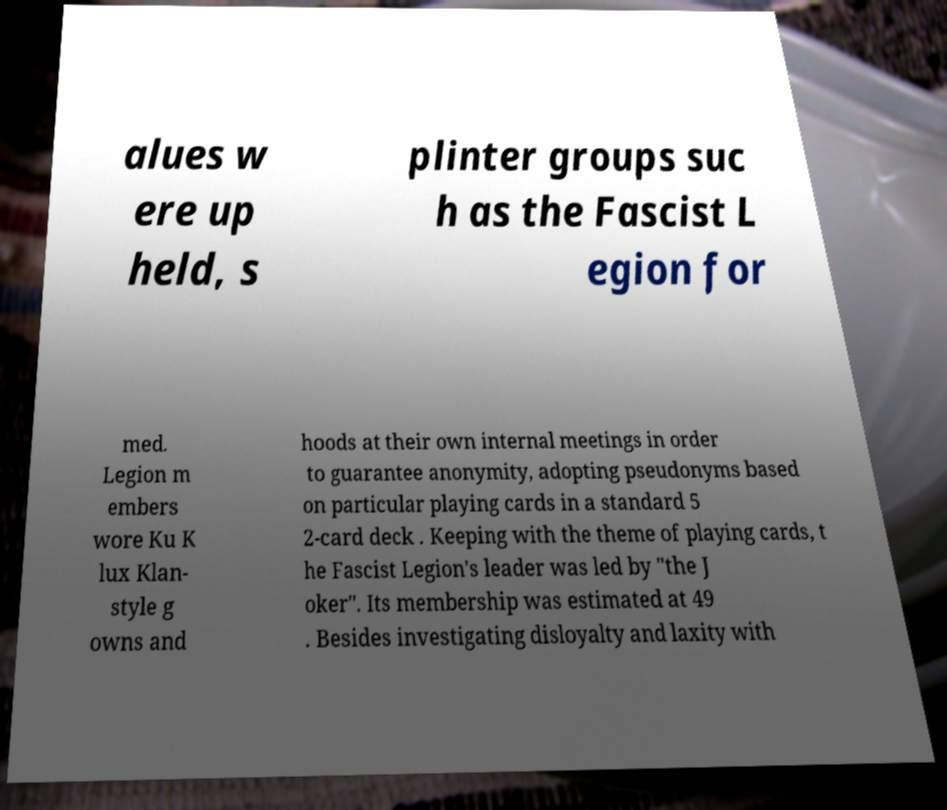For documentation purposes, I need the text within this image transcribed. Could you provide that? alues w ere up held, s plinter groups suc h as the Fascist L egion for med. Legion m embers wore Ku K lux Klan- style g owns and hoods at their own internal meetings in order to guarantee anonymity, adopting pseudonyms based on particular playing cards in a standard 5 2-card deck . Keeping with the theme of playing cards, t he Fascist Legion's leader was led by "the J oker". Its membership was estimated at 49 . Besides investigating disloyalty and laxity with 